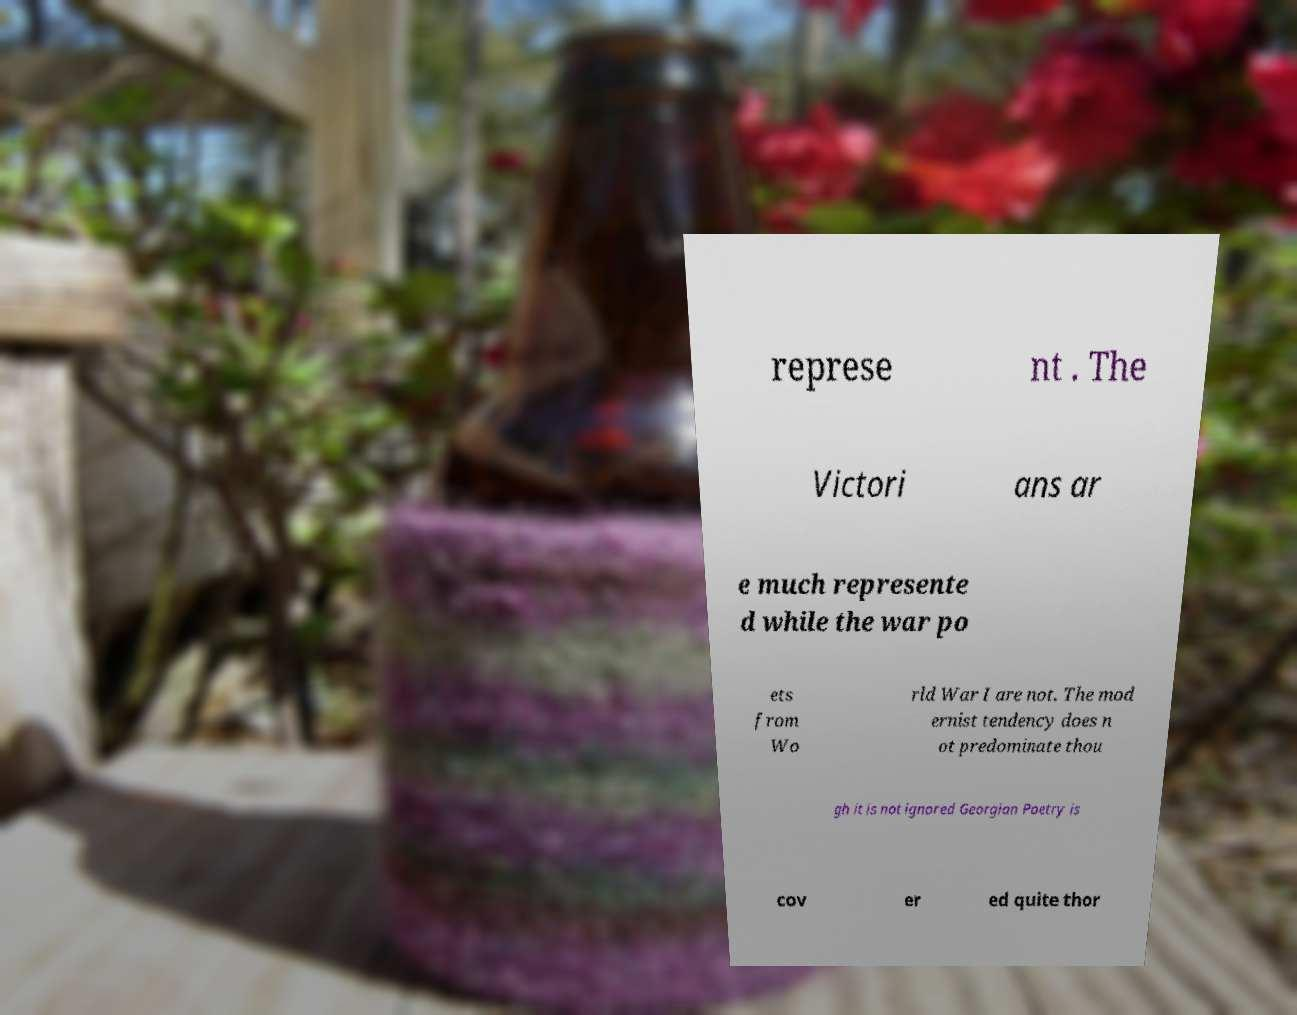Could you assist in decoding the text presented in this image and type it out clearly? represe nt . The Victori ans ar e much represente d while the war po ets from Wo rld War I are not. The mod ernist tendency does n ot predominate thou gh it is not ignored Georgian Poetry is cov er ed quite thor 